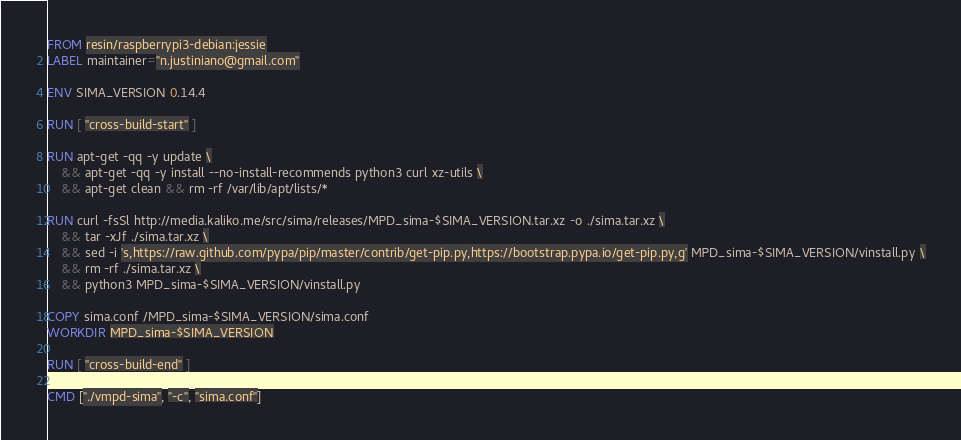Convert code to text. <code><loc_0><loc_0><loc_500><loc_500><_Dockerfile_>FROM resin/raspberrypi3-debian:jessie
LABEL maintainer="n.justiniano@gmail.com"

ENV SIMA_VERSION 0.14.4

RUN [ "cross-build-start" ]

RUN apt-get -qq -y update \
    && apt-get -qq -y install --no-install-recommends python3 curl xz-utils \
    && apt-get clean && rm -rf /var/lib/apt/lists/*

RUN curl -fsSl http://media.kaliko.me/src/sima/releases/MPD_sima-$SIMA_VERSION.tar.xz -o ./sima.tar.xz \
    && tar -xJf ./sima.tar.xz \
    && sed -i 's,https://raw.github.com/pypa/pip/master/contrib/get-pip.py,https://bootstrap.pypa.io/get-pip.py,g' MPD_sima-$SIMA_VERSION/vinstall.py \
    && rm -rf ./sima.tar.xz \
    && python3 MPD_sima-$SIMA_VERSION/vinstall.py
    
COPY sima.conf /MPD_sima-$SIMA_VERSION/sima.conf
WORKDIR MPD_sima-$SIMA_VERSION

RUN [ "cross-build-end" ]

CMD ["./vmpd-sima", "-c", "sima.conf"]
</code> 